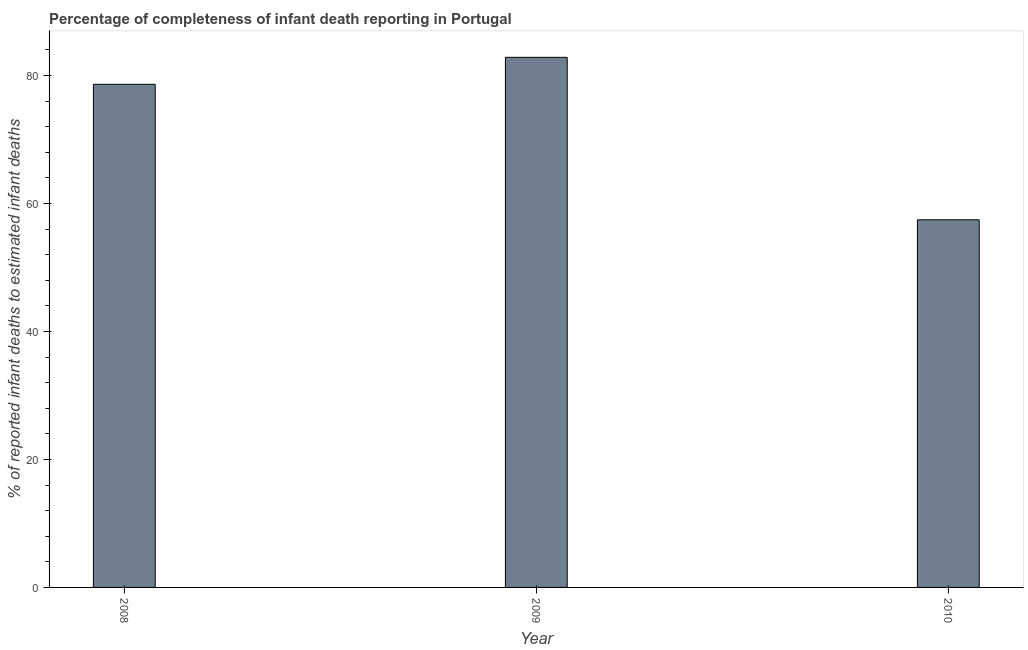Does the graph contain any zero values?
Your answer should be compact. No. What is the title of the graph?
Ensure brevity in your answer.  Percentage of completeness of infant death reporting in Portugal. What is the label or title of the X-axis?
Ensure brevity in your answer.  Year. What is the label or title of the Y-axis?
Your answer should be very brief. % of reported infant deaths to estimated infant deaths. What is the completeness of infant death reporting in 2010?
Offer a very short reply. 57.45. Across all years, what is the maximum completeness of infant death reporting?
Your response must be concise. 82.84. Across all years, what is the minimum completeness of infant death reporting?
Offer a very short reply. 57.45. In which year was the completeness of infant death reporting minimum?
Provide a short and direct response. 2010. What is the sum of the completeness of infant death reporting?
Offer a terse response. 218.9. What is the difference between the completeness of infant death reporting in 2008 and 2010?
Provide a succinct answer. 21.17. What is the average completeness of infant death reporting per year?
Keep it short and to the point. 72.97. What is the median completeness of infant death reporting?
Offer a very short reply. 78.62. Do a majority of the years between 2008 and 2009 (inclusive) have completeness of infant death reporting greater than 56 %?
Offer a very short reply. Yes. What is the ratio of the completeness of infant death reporting in 2009 to that in 2010?
Offer a very short reply. 1.44. Is the difference between the completeness of infant death reporting in 2008 and 2010 greater than the difference between any two years?
Keep it short and to the point. No. What is the difference between the highest and the second highest completeness of infant death reporting?
Keep it short and to the point. 4.22. Is the sum of the completeness of infant death reporting in 2008 and 2010 greater than the maximum completeness of infant death reporting across all years?
Provide a short and direct response. Yes. What is the difference between the highest and the lowest completeness of infant death reporting?
Offer a very short reply. 25.39. In how many years, is the completeness of infant death reporting greater than the average completeness of infant death reporting taken over all years?
Offer a very short reply. 2. How many bars are there?
Keep it short and to the point. 3. How many years are there in the graph?
Make the answer very short. 3. What is the difference between two consecutive major ticks on the Y-axis?
Offer a terse response. 20. What is the % of reported infant deaths to estimated infant deaths in 2008?
Provide a succinct answer. 78.62. What is the % of reported infant deaths to estimated infant deaths in 2009?
Your answer should be compact. 82.84. What is the % of reported infant deaths to estimated infant deaths of 2010?
Ensure brevity in your answer.  57.45. What is the difference between the % of reported infant deaths to estimated infant deaths in 2008 and 2009?
Provide a short and direct response. -4.22. What is the difference between the % of reported infant deaths to estimated infant deaths in 2008 and 2010?
Your answer should be very brief. 21.17. What is the difference between the % of reported infant deaths to estimated infant deaths in 2009 and 2010?
Ensure brevity in your answer.  25.39. What is the ratio of the % of reported infant deaths to estimated infant deaths in 2008 to that in 2009?
Give a very brief answer. 0.95. What is the ratio of the % of reported infant deaths to estimated infant deaths in 2008 to that in 2010?
Your answer should be compact. 1.37. What is the ratio of the % of reported infant deaths to estimated infant deaths in 2009 to that in 2010?
Ensure brevity in your answer.  1.44. 